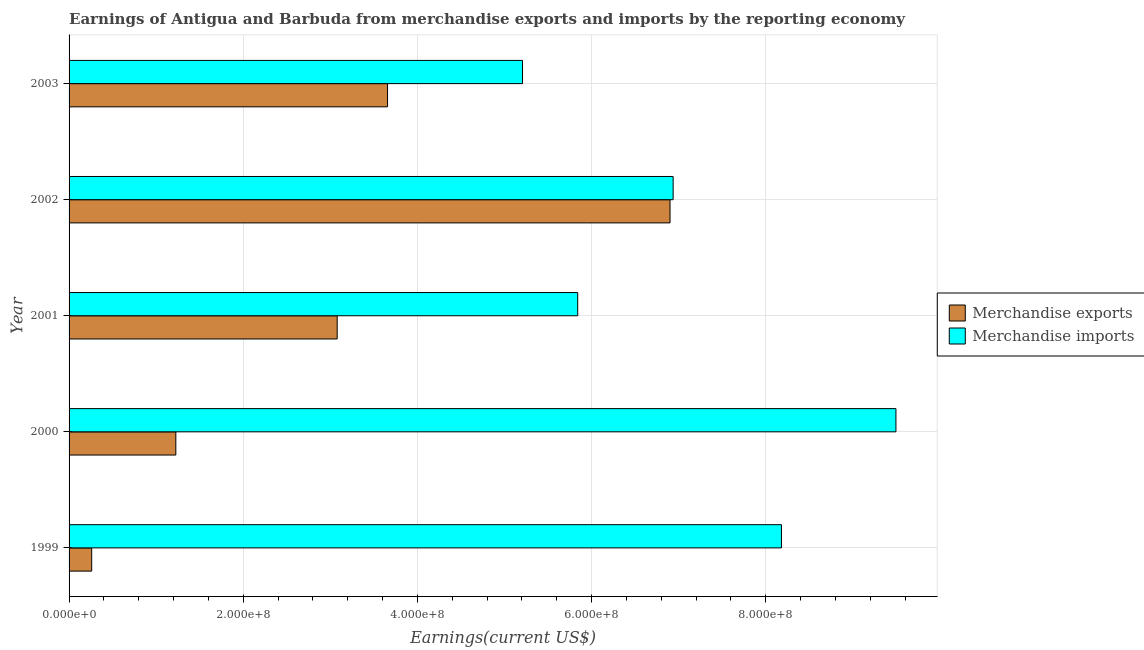How many different coloured bars are there?
Give a very brief answer. 2. How many groups of bars are there?
Make the answer very short. 5. Are the number of bars on each tick of the Y-axis equal?
Offer a very short reply. Yes. How many bars are there on the 3rd tick from the bottom?
Ensure brevity in your answer.  2. What is the label of the 5th group of bars from the top?
Make the answer very short. 1999. In how many cases, is the number of bars for a given year not equal to the number of legend labels?
Your response must be concise. 0. What is the earnings from merchandise exports in 2002?
Offer a terse response. 6.90e+08. Across all years, what is the maximum earnings from merchandise imports?
Keep it short and to the point. 9.50e+08. Across all years, what is the minimum earnings from merchandise exports?
Offer a terse response. 2.60e+07. In which year was the earnings from merchandise imports minimum?
Provide a short and direct response. 2003. What is the total earnings from merchandise imports in the graph?
Give a very brief answer. 3.57e+09. What is the difference between the earnings from merchandise imports in 1999 and that in 2002?
Ensure brevity in your answer.  1.24e+08. What is the difference between the earnings from merchandise imports in 2001 and the earnings from merchandise exports in 2003?
Make the answer very short. 2.18e+08. What is the average earnings from merchandise imports per year?
Provide a short and direct response. 7.13e+08. In the year 2001, what is the difference between the earnings from merchandise exports and earnings from merchandise imports?
Provide a short and direct response. -2.76e+08. In how many years, is the earnings from merchandise exports greater than 360000000 US$?
Your answer should be very brief. 2. What is the ratio of the earnings from merchandise exports in 2000 to that in 2002?
Offer a terse response. 0.18. Is the earnings from merchandise imports in 1999 less than that in 2001?
Provide a short and direct response. No. What is the difference between the highest and the second highest earnings from merchandise exports?
Offer a very short reply. 3.24e+08. What is the difference between the highest and the lowest earnings from merchandise imports?
Make the answer very short. 4.29e+08. In how many years, is the earnings from merchandise exports greater than the average earnings from merchandise exports taken over all years?
Offer a terse response. 3. What does the 1st bar from the top in 2000 represents?
Offer a very short reply. Merchandise imports. How many years are there in the graph?
Make the answer very short. 5. What is the difference between two consecutive major ticks on the X-axis?
Keep it short and to the point. 2.00e+08. Does the graph contain any zero values?
Provide a succinct answer. No. Does the graph contain grids?
Offer a very short reply. Yes. Where does the legend appear in the graph?
Give a very brief answer. Center right. How are the legend labels stacked?
Your answer should be very brief. Vertical. What is the title of the graph?
Give a very brief answer. Earnings of Antigua and Barbuda from merchandise exports and imports by the reporting economy. What is the label or title of the X-axis?
Ensure brevity in your answer.  Earnings(current US$). What is the label or title of the Y-axis?
Your response must be concise. Year. What is the Earnings(current US$) of Merchandise exports in 1999?
Your answer should be very brief. 2.60e+07. What is the Earnings(current US$) in Merchandise imports in 1999?
Ensure brevity in your answer.  8.18e+08. What is the Earnings(current US$) in Merchandise exports in 2000?
Provide a short and direct response. 1.23e+08. What is the Earnings(current US$) of Merchandise imports in 2000?
Provide a short and direct response. 9.50e+08. What is the Earnings(current US$) of Merchandise exports in 2001?
Make the answer very short. 3.08e+08. What is the Earnings(current US$) in Merchandise imports in 2001?
Make the answer very short. 5.84e+08. What is the Earnings(current US$) in Merchandise exports in 2002?
Offer a very short reply. 6.90e+08. What is the Earnings(current US$) in Merchandise imports in 2002?
Offer a very short reply. 6.94e+08. What is the Earnings(current US$) in Merchandise exports in 2003?
Offer a very short reply. 3.66e+08. What is the Earnings(current US$) of Merchandise imports in 2003?
Give a very brief answer. 5.21e+08. Across all years, what is the maximum Earnings(current US$) of Merchandise exports?
Make the answer very short. 6.90e+08. Across all years, what is the maximum Earnings(current US$) in Merchandise imports?
Offer a terse response. 9.50e+08. Across all years, what is the minimum Earnings(current US$) in Merchandise exports?
Ensure brevity in your answer.  2.60e+07. Across all years, what is the minimum Earnings(current US$) in Merchandise imports?
Offer a very short reply. 5.21e+08. What is the total Earnings(current US$) in Merchandise exports in the graph?
Offer a very short reply. 1.51e+09. What is the total Earnings(current US$) of Merchandise imports in the graph?
Keep it short and to the point. 3.57e+09. What is the difference between the Earnings(current US$) in Merchandise exports in 1999 and that in 2000?
Your answer should be compact. -9.66e+07. What is the difference between the Earnings(current US$) of Merchandise imports in 1999 and that in 2000?
Your answer should be very brief. -1.31e+08. What is the difference between the Earnings(current US$) of Merchandise exports in 1999 and that in 2001?
Offer a very short reply. -2.82e+08. What is the difference between the Earnings(current US$) in Merchandise imports in 1999 and that in 2001?
Your answer should be compact. 2.34e+08. What is the difference between the Earnings(current US$) of Merchandise exports in 1999 and that in 2002?
Your answer should be very brief. -6.64e+08. What is the difference between the Earnings(current US$) in Merchandise imports in 1999 and that in 2002?
Your response must be concise. 1.24e+08. What is the difference between the Earnings(current US$) in Merchandise exports in 1999 and that in 2003?
Keep it short and to the point. -3.40e+08. What is the difference between the Earnings(current US$) in Merchandise imports in 1999 and that in 2003?
Your answer should be compact. 2.97e+08. What is the difference between the Earnings(current US$) in Merchandise exports in 2000 and that in 2001?
Your answer should be compact. -1.85e+08. What is the difference between the Earnings(current US$) of Merchandise imports in 2000 and that in 2001?
Provide a short and direct response. 3.65e+08. What is the difference between the Earnings(current US$) of Merchandise exports in 2000 and that in 2002?
Your answer should be very brief. -5.68e+08. What is the difference between the Earnings(current US$) in Merchandise imports in 2000 and that in 2002?
Your answer should be compact. 2.56e+08. What is the difference between the Earnings(current US$) in Merchandise exports in 2000 and that in 2003?
Ensure brevity in your answer.  -2.43e+08. What is the difference between the Earnings(current US$) of Merchandise imports in 2000 and that in 2003?
Your answer should be compact. 4.29e+08. What is the difference between the Earnings(current US$) of Merchandise exports in 2001 and that in 2002?
Your answer should be compact. -3.82e+08. What is the difference between the Earnings(current US$) in Merchandise imports in 2001 and that in 2002?
Ensure brevity in your answer.  -1.10e+08. What is the difference between the Earnings(current US$) of Merchandise exports in 2001 and that in 2003?
Make the answer very short. -5.78e+07. What is the difference between the Earnings(current US$) of Merchandise imports in 2001 and that in 2003?
Make the answer very short. 6.34e+07. What is the difference between the Earnings(current US$) of Merchandise exports in 2002 and that in 2003?
Ensure brevity in your answer.  3.24e+08. What is the difference between the Earnings(current US$) of Merchandise imports in 2002 and that in 2003?
Provide a succinct answer. 1.73e+08. What is the difference between the Earnings(current US$) of Merchandise exports in 1999 and the Earnings(current US$) of Merchandise imports in 2000?
Make the answer very short. -9.24e+08. What is the difference between the Earnings(current US$) in Merchandise exports in 1999 and the Earnings(current US$) in Merchandise imports in 2001?
Give a very brief answer. -5.58e+08. What is the difference between the Earnings(current US$) in Merchandise exports in 1999 and the Earnings(current US$) in Merchandise imports in 2002?
Provide a short and direct response. -6.68e+08. What is the difference between the Earnings(current US$) in Merchandise exports in 1999 and the Earnings(current US$) in Merchandise imports in 2003?
Keep it short and to the point. -4.95e+08. What is the difference between the Earnings(current US$) of Merchandise exports in 2000 and the Earnings(current US$) of Merchandise imports in 2001?
Your answer should be very brief. -4.62e+08. What is the difference between the Earnings(current US$) in Merchandise exports in 2000 and the Earnings(current US$) in Merchandise imports in 2002?
Offer a terse response. -5.71e+08. What is the difference between the Earnings(current US$) of Merchandise exports in 2000 and the Earnings(current US$) of Merchandise imports in 2003?
Provide a short and direct response. -3.98e+08. What is the difference between the Earnings(current US$) in Merchandise exports in 2001 and the Earnings(current US$) in Merchandise imports in 2002?
Make the answer very short. -3.86e+08. What is the difference between the Earnings(current US$) in Merchandise exports in 2001 and the Earnings(current US$) in Merchandise imports in 2003?
Keep it short and to the point. -2.13e+08. What is the difference between the Earnings(current US$) in Merchandise exports in 2002 and the Earnings(current US$) in Merchandise imports in 2003?
Ensure brevity in your answer.  1.69e+08. What is the average Earnings(current US$) of Merchandise exports per year?
Provide a succinct answer. 3.02e+08. What is the average Earnings(current US$) of Merchandise imports per year?
Offer a very short reply. 7.13e+08. In the year 1999, what is the difference between the Earnings(current US$) in Merchandise exports and Earnings(current US$) in Merchandise imports?
Offer a very short reply. -7.92e+08. In the year 2000, what is the difference between the Earnings(current US$) in Merchandise exports and Earnings(current US$) in Merchandise imports?
Provide a succinct answer. -8.27e+08. In the year 2001, what is the difference between the Earnings(current US$) of Merchandise exports and Earnings(current US$) of Merchandise imports?
Your answer should be compact. -2.76e+08. In the year 2002, what is the difference between the Earnings(current US$) of Merchandise exports and Earnings(current US$) of Merchandise imports?
Give a very brief answer. -3.57e+06. In the year 2003, what is the difference between the Earnings(current US$) of Merchandise exports and Earnings(current US$) of Merchandise imports?
Provide a succinct answer. -1.55e+08. What is the ratio of the Earnings(current US$) of Merchandise exports in 1999 to that in 2000?
Make the answer very short. 0.21. What is the ratio of the Earnings(current US$) in Merchandise imports in 1999 to that in 2000?
Your answer should be very brief. 0.86. What is the ratio of the Earnings(current US$) of Merchandise exports in 1999 to that in 2001?
Your response must be concise. 0.08. What is the ratio of the Earnings(current US$) of Merchandise imports in 1999 to that in 2001?
Provide a succinct answer. 1.4. What is the ratio of the Earnings(current US$) of Merchandise exports in 1999 to that in 2002?
Offer a very short reply. 0.04. What is the ratio of the Earnings(current US$) of Merchandise imports in 1999 to that in 2002?
Provide a short and direct response. 1.18. What is the ratio of the Earnings(current US$) of Merchandise exports in 1999 to that in 2003?
Make the answer very short. 0.07. What is the ratio of the Earnings(current US$) of Merchandise imports in 1999 to that in 2003?
Your response must be concise. 1.57. What is the ratio of the Earnings(current US$) in Merchandise exports in 2000 to that in 2001?
Offer a terse response. 0.4. What is the ratio of the Earnings(current US$) of Merchandise imports in 2000 to that in 2001?
Give a very brief answer. 1.63. What is the ratio of the Earnings(current US$) in Merchandise exports in 2000 to that in 2002?
Offer a very short reply. 0.18. What is the ratio of the Earnings(current US$) of Merchandise imports in 2000 to that in 2002?
Your answer should be very brief. 1.37. What is the ratio of the Earnings(current US$) in Merchandise exports in 2000 to that in 2003?
Your answer should be compact. 0.34. What is the ratio of the Earnings(current US$) in Merchandise imports in 2000 to that in 2003?
Keep it short and to the point. 1.82. What is the ratio of the Earnings(current US$) of Merchandise exports in 2001 to that in 2002?
Your answer should be very brief. 0.45. What is the ratio of the Earnings(current US$) in Merchandise imports in 2001 to that in 2002?
Give a very brief answer. 0.84. What is the ratio of the Earnings(current US$) in Merchandise exports in 2001 to that in 2003?
Ensure brevity in your answer.  0.84. What is the ratio of the Earnings(current US$) in Merchandise imports in 2001 to that in 2003?
Ensure brevity in your answer.  1.12. What is the ratio of the Earnings(current US$) in Merchandise exports in 2002 to that in 2003?
Keep it short and to the point. 1.89. What is the ratio of the Earnings(current US$) of Merchandise imports in 2002 to that in 2003?
Provide a short and direct response. 1.33. What is the difference between the highest and the second highest Earnings(current US$) in Merchandise exports?
Your answer should be very brief. 3.24e+08. What is the difference between the highest and the second highest Earnings(current US$) of Merchandise imports?
Offer a very short reply. 1.31e+08. What is the difference between the highest and the lowest Earnings(current US$) of Merchandise exports?
Make the answer very short. 6.64e+08. What is the difference between the highest and the lowest Earnings(current US$) of Merchandise imports?
Your response must be concise. 4.29e+08. 